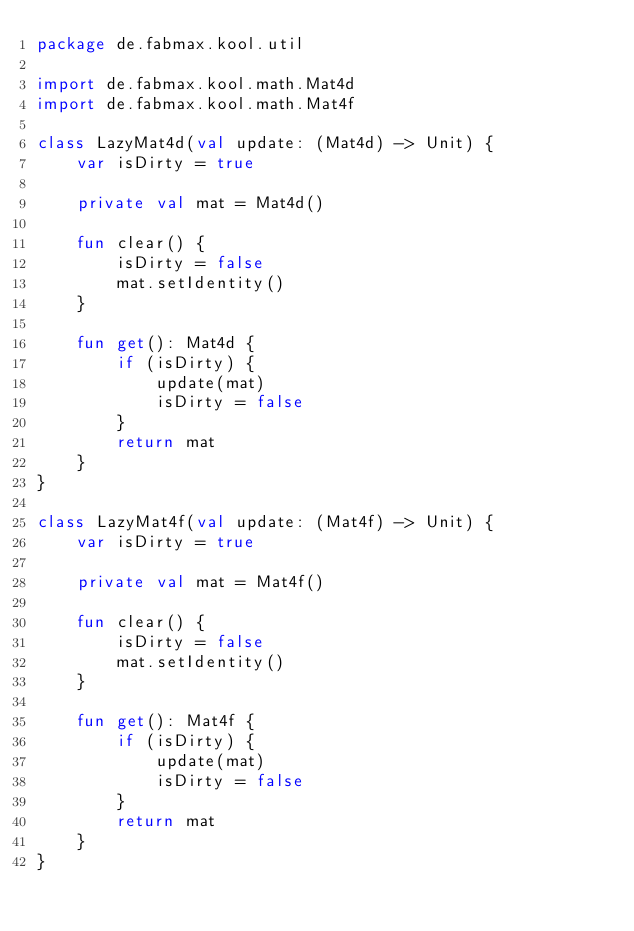Convert code to text. <code><loc_0><loc_0><loc_500><loc_500><_Kotlin_>package de.fabmax.kool.util

import de.fabmax.kool.math.Mat4d
import de.fabmax.kool.math.Mat4f

class LazyMat4d(val update: (Mat4d) -> Unit) {
    var isDirty = true

    private val mat = Mat4d()

    fun clear() {
        isDirty = false
        mat.setIdentity()
    }

    fun get(): Mat4d {
        if (isDirty) {
            update(mat)
            isDirty = false
        }
        return mat
    }
}

class LazyMat4f(val update: (Mat4f) -> Unit) {
    var isDirty = true

    private val mat = Mat4f()

    fun clear() {
        isDirty = false
        mat.setIdentity()
    }

    fun get(): Mat4f {
        if (isDirty) {
            update(mat)
            isDirty = false
        }
        return mat
    }
}</code> 